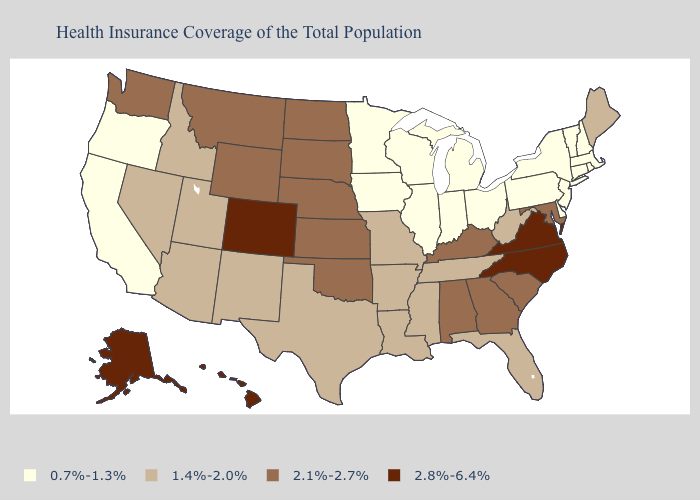Does Maine have the lowest value in the Northeast?
Short answer required. No. Does Oklahoma have a higher value than Vermont?
Write a very short answer. Yes. Does Hawaii have the same value as Alaska?
Write a very short answer. Yes. What is the value of Florida?
Write a very short answer. 1.4%-2.0%. What is the lowest value in states that border Mississippi?
Give a very brief answer. 1.4%-2.0%. What is the value of Arkansas?
Quick response, please. 1.4%-2.0%. Name the states that have a value in the range 0.7%-1.3%?
Give a very brief answer. California, Connecticut, Delaware, Illinois, Indiana, Iowa, Massachusetts, Michigan, Minnesota, New Hampshire, New Jersey, New York, Ohio, Oregon, Pennsylvania, Rhode Island, Vermont, Wisconsin. Does Nebraska have the same value as Washington?
Keep it brief. Yes. Which states have the lowest value in the USA?
Quick response, please. California, Connecticut, Delaware, Illinois, Indiana, Iowa, Massachusetts, Michigan, Minnesota, New Hampshire, New Jersey, New York, Ohio, Oregon, Pennsylvania, Rhode Island, Vermont, Wisconsin. What is the value of Maryland?
Give a very brief answer. 2.1%-2.7%. Does New Jersey have the highest value in the Northeast?
Short answer required. No. What is the value of Pennsylvania?
Be succinct. 0.7%-1.3%. Does Georgia have a higher value than Hawaii?
Be succinct. No. Does Illinois have the same value as Colorado?
Write a very short answer. No. 